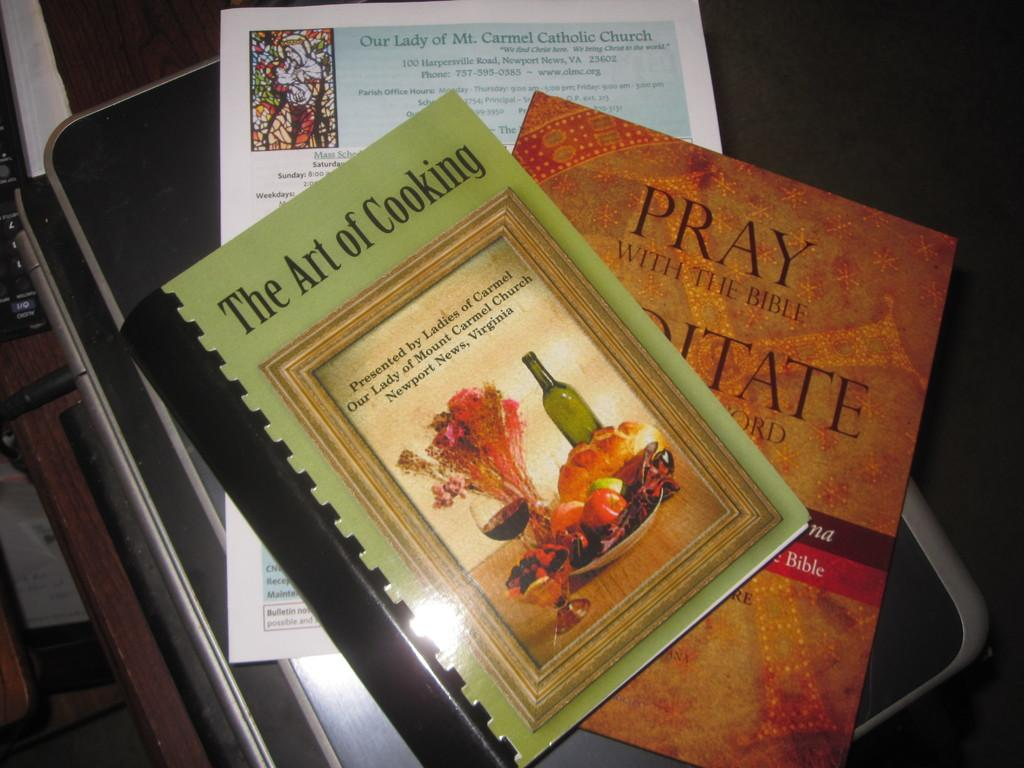<image>
Share a concise interpretation of the image provided. The Art of Cooking is on top of another book. 